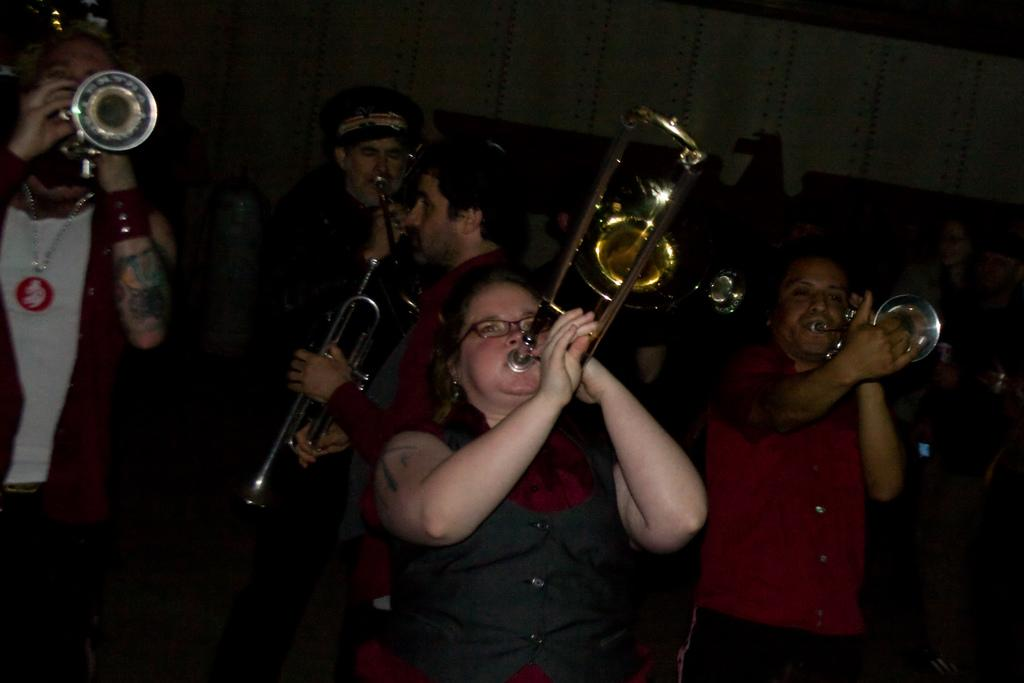What are the people in the image doing? The people in the image are playing trumpets. Can you describe the background of the image? There is a wall visible in the background of the image. Is there a volcano erupting in the background of the image? No, there is no volcano present in the image. Can you tell me where the nearest shop is located in the image? There is no information about a shop in the image. 